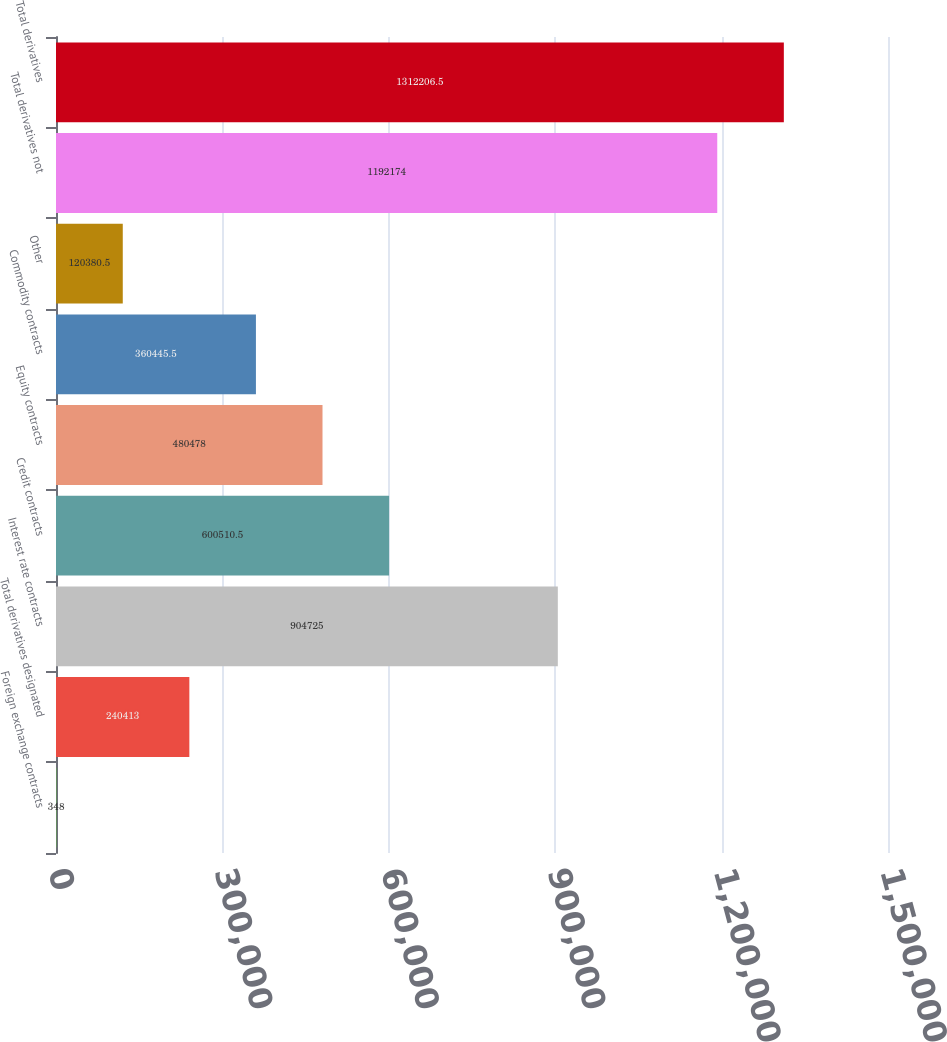Convert chart. <chart><loc_0><loc_0><loc_500><loc_500><bar_chart><fcel>Foreign exchange contracts<fcel>Total derivatives designated<fcel>Interest rate contracts<fcel>Credit contracts<fcel>Equity contracts<fcel>Commodity contracts<fcel>Other<fcel>Total derivatives not<fcel>Total derivatives<nl><fcel>348<fcel>240413<fcel>904725<fcel>600510<fcel>480478<fcel>360446<fcel>120380<fcel>1.19217e+06<fcel>1.31221e+06<nl></chart> 